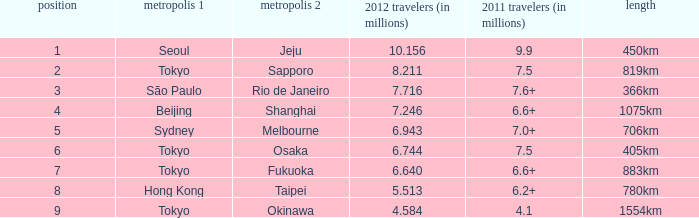Which city is listed first when Okinawa is listed as the second city? Tokyo. 